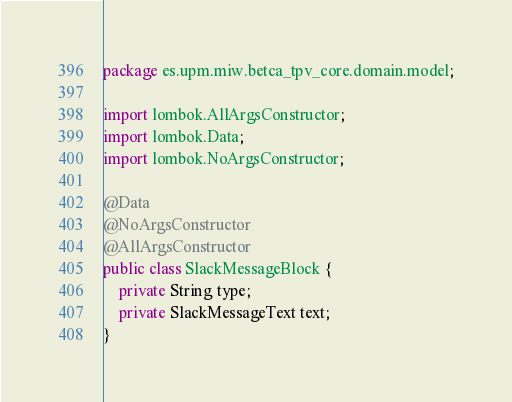<code> <loc_0><loc_0><loc_500><loc_500><_Java_>package es.upm.miw.betca_tpv_core.domain.model;

import lombok.AllArgsConstructor;
import lombok.Data;
import lombok.NoArgsConstructor;

@Data
@NoArgsConstructor
@AllArgsConstructor
public class SlackMessageBlock {
    private String type;
    private SlackMessageText text;
}
</code> 